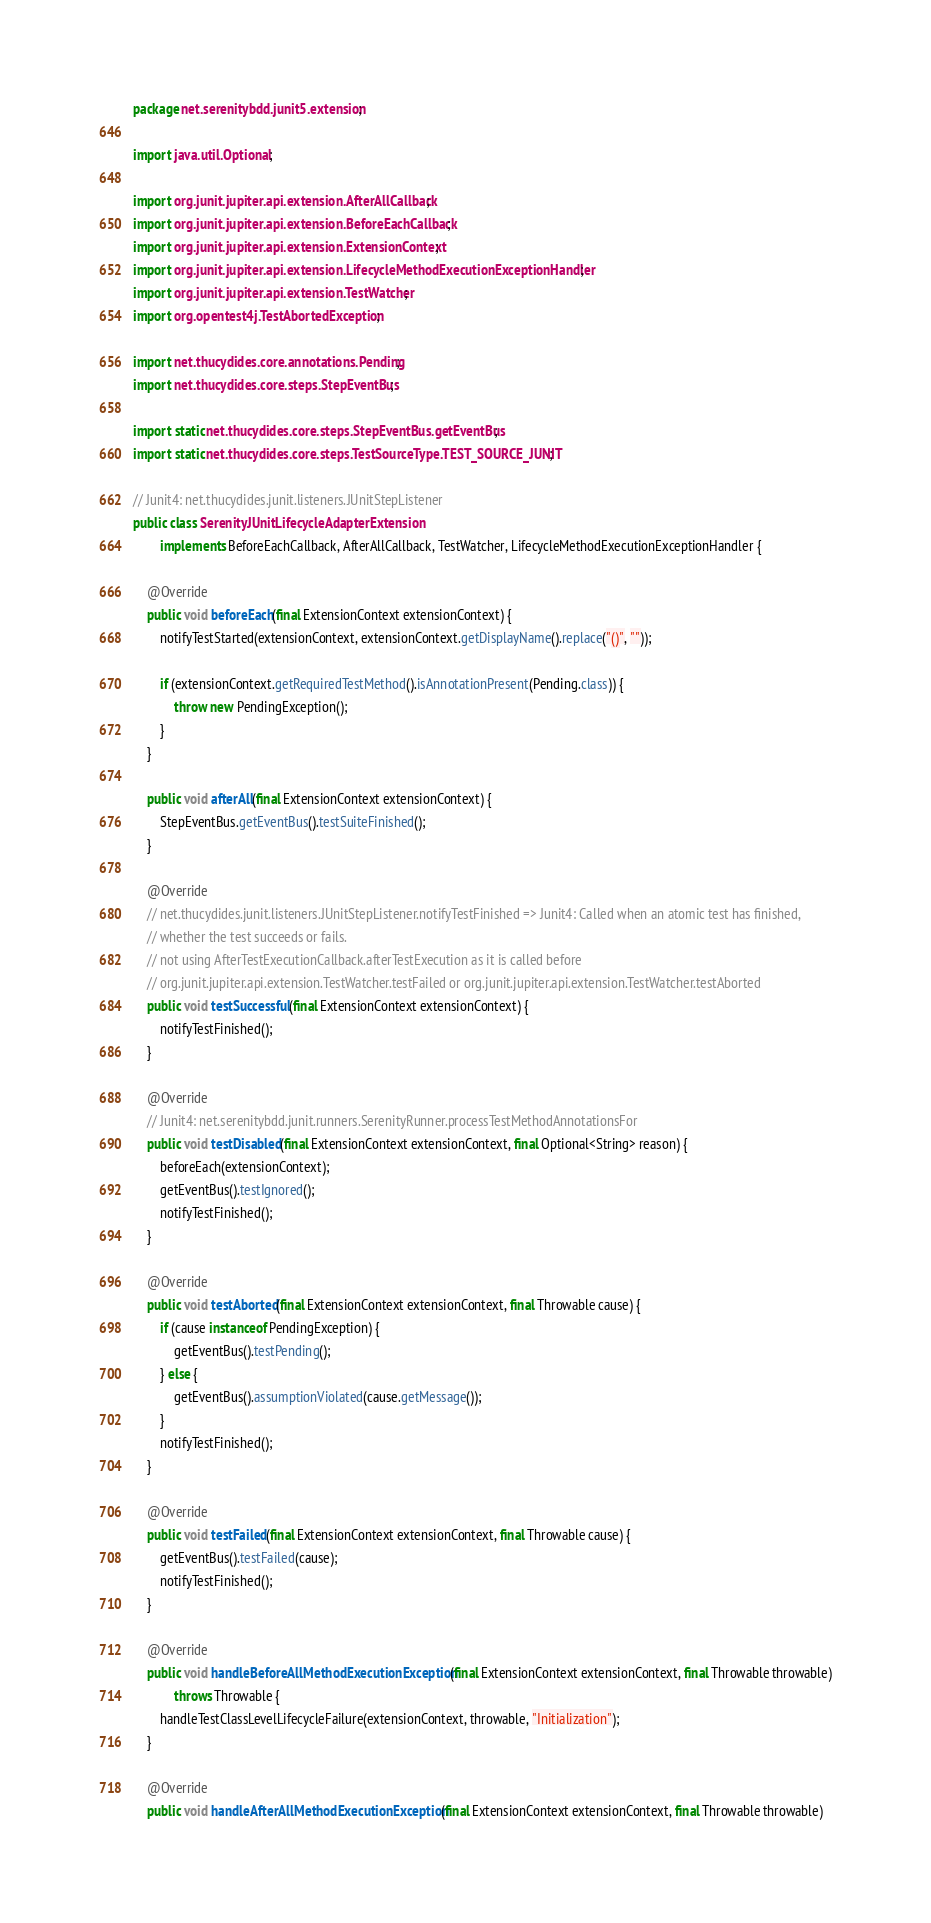<code> <loc_0><loc_0><loc_500><loc_500><_Java_>package net.serenitybdd.junit5.extension;

import java.util.Optional;

import org.junit.jupiter.api.extension.AfterAllCallback;
import org.junit.jupiter.api.extension.BeforeEachCallback;
import org.junit.jupiter.api.extension.ExtensionContext;
import org.junit.jupiter.api.extension.LifecycleMethodExecutionExceptionHandler;
import org.junit.jupiter.api.extension.TestWatcher;
import org.opentest4j.TestAbortedException;

import net.thucydides.core.annotations.Pending;
import net.thucydides.core.steps.StepEventBus;

import static net.thucydides.core.steps.StepEventBus.getEventBus;
import static net.thucydides.core.steps.TestSourceType.TEST_SOURCE_JUNIT;

// Junit4: net.thucydides.junit.listeners.JUnitStepListener
public class SerenityJUnitLifecycleAdapterExtension
        implements BeforeEachCallback, AfterAllCallback, TestWatcher, LifecycleMethodExecutionExceptionHandler {

    @Override
    public void beforeEach(final ExtensionContext extensionContext) {
        notifyTestStarted(extensionContext, extensionContext.getDisplayName().replace("()", ""));

        if (extensionContext.getRequiredTestMethod().isAnnotationPresent(Pending.class)) {
            throw new PendingException();
        }
    }

    public void afterAll(final ExtensionContext extensionContext) {
        StepEventBus.getEventBus().testSuiteFinished();
    }

    @Override
    // net.thucydides.junit.listeners.JUnitStepListener.notifyTestFinished => Junit4: Called when an atomic test has finished,
    // whether the test succeeds or fails.
    // not using AfterTestExecutionCallback.afterTestExecution as it is called before
    // org.junit.jupiter.api.extension.TestWatcher.testFailed or org.junit.jupiter.api.extension.TestWatcher.testAborted
    public void testSuccessful(final ExtensionContext extensionContext) {
        notifyTestFinished();
    }

    @Override
    // Junit4: net.serenitybdd.junit.runners.SerenityRunner.processTestMethodAnnotationsFor
    public void testDisabled(final ExtensionContext extensionContext, final Optional<String> reason) {
        beforeEach(extensionContext);
        getEventBus().testIgnored();
        notifyTestFinished();
    }

    @Override
    public void testAborted(final ExtensionContext extensionContext, final Throwable cause) {
        if (cause instanceof PendingException) {
            getEventBus().testPending();
        } else {
            getEventBus().assumptionViolated(cause.getMessage());
        }
        notifyTestFinished();
    }

    @Override
    public void testFailed(final ExtensionContext extensionContext, final Throwable cause) {
        getEventBus().testFailed(cause);
        notifyTestFinished();
    }

    @Override
    public void handleBeforeAllMethodExecutionException(final ExtensionContext extensionContext, final Throwable throwable)
            throws Throwable {
        handleTestClassLevelLifecycleFailure(extensionContext, throwable, "Initialization");
    }

    @Override
    public void handleAfterAllMethodExecutionException(final ExtensionContext extensionContext, final Throwable throwable)</code> 